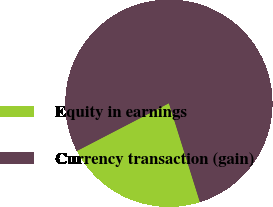Convert chart. <chart><loc_0><loc_0><loc_500><loc_500><pie_chart><fcel>Equity in earnings<fcel>Currency transaction (gain)<nl><fcel>22.22%<fcel>77.78%<nl></chart> 